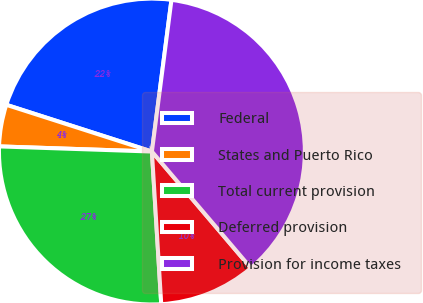Convert chart to OTSL. <chart><loc_0><loc_0><loc_500><loc_500><pie_chart><fcel>Federal<fcel>States and Puerto Rico<fcel>Total current provision<fcel>Deferred provision<fcel>Provision for income taxes<nl><fcel>22.1%<fcel>4.41%<fcel>26.51%<fcel>10.24%<fcel>36.75%<nl></chart> 